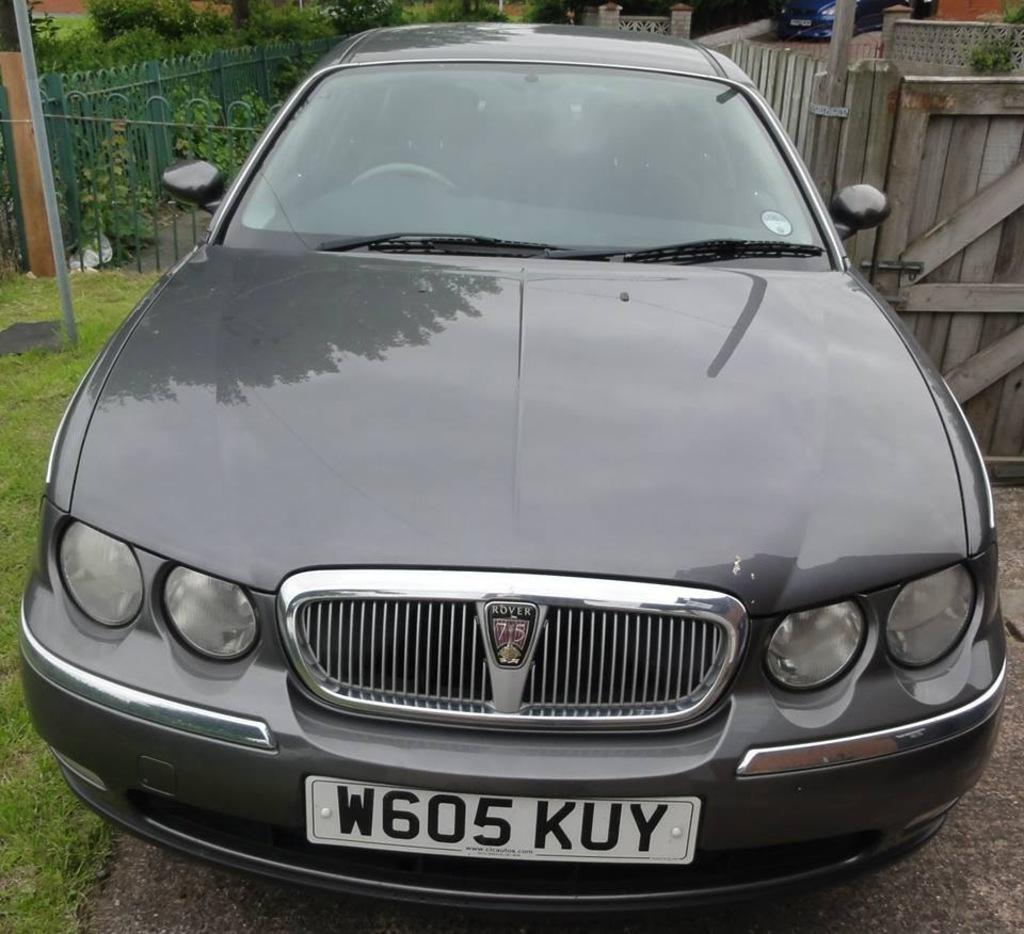<image>
Render a clear and concise summary of the photo. Car with the tag on the front of it that is W605 KUY 